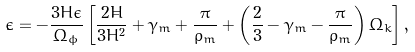<formula> <loc_0><loc_0><loc_500><loc_500>\dot { \epsilon } = - \frac { 3 H \epsilon } { \Omega _ { \phi } } \left [ \frac { 2 \dot { H } } { 3 H ^ { 2 } } + \gamma _ { m } + \frac { \pi } { \rho _ { m } } + \left ( \frac { 2 } { 3 } - \gamma _ { m } - \frac { \pi } { \rho _ { m } } \right ) \Omega _ { k } \right ] ,</formula> 